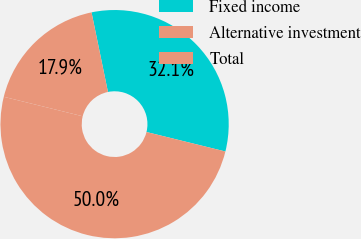Convert chart. <chart><loc_0><loc_0><loc_500><loc_500><pie_chart><fcel>Fixed income<fcel>Alternative investment<fcel>Total<nl><fcel>32.09%<fcel>17.91%<fcel>50.0%<nl></chart> 